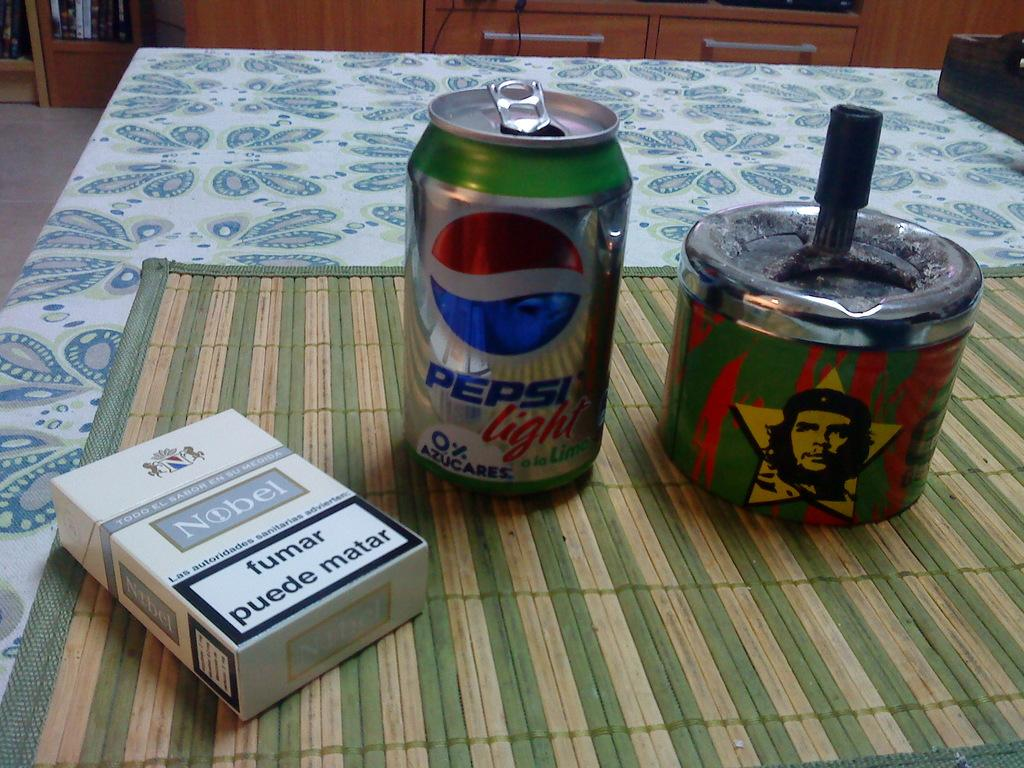<image>
Relay a brief, clear account of the picture shown. A pack of Nobel cigarettes is on a table next to a can of Pepsi light. 